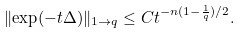Convert formula to latex. <formula><loc_0><loc_0><loc_500><loc_500>\| { \exp ( - t \Delta ) } \| _ { 1 \to q } \leq C t ^ { - n ( 1 - \frac { 1 } { q } ) / 2 } .</formula> 